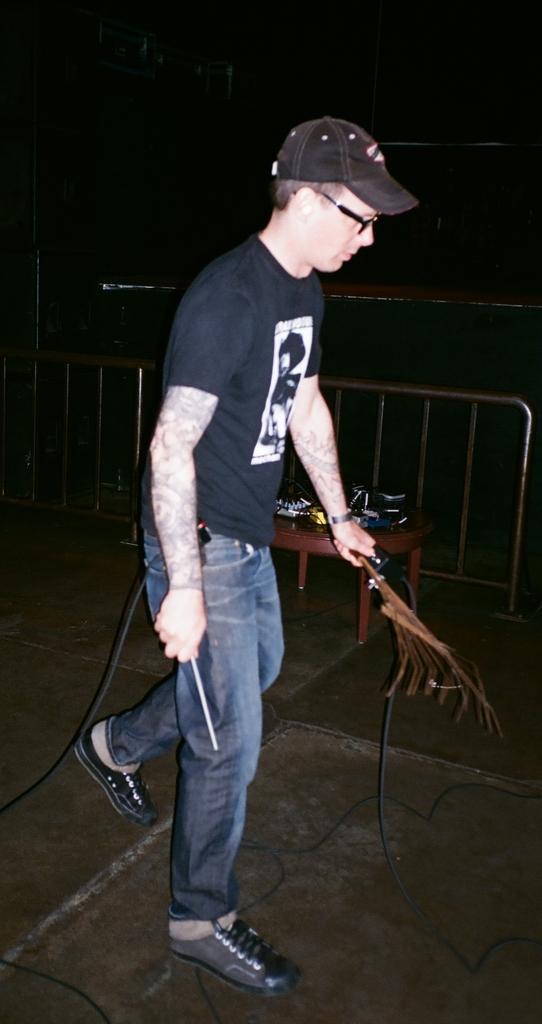Describe this image in one or two sentences. In this image we can see one person standing and holding an object, near there is a table and few objects on it, metal fence. 